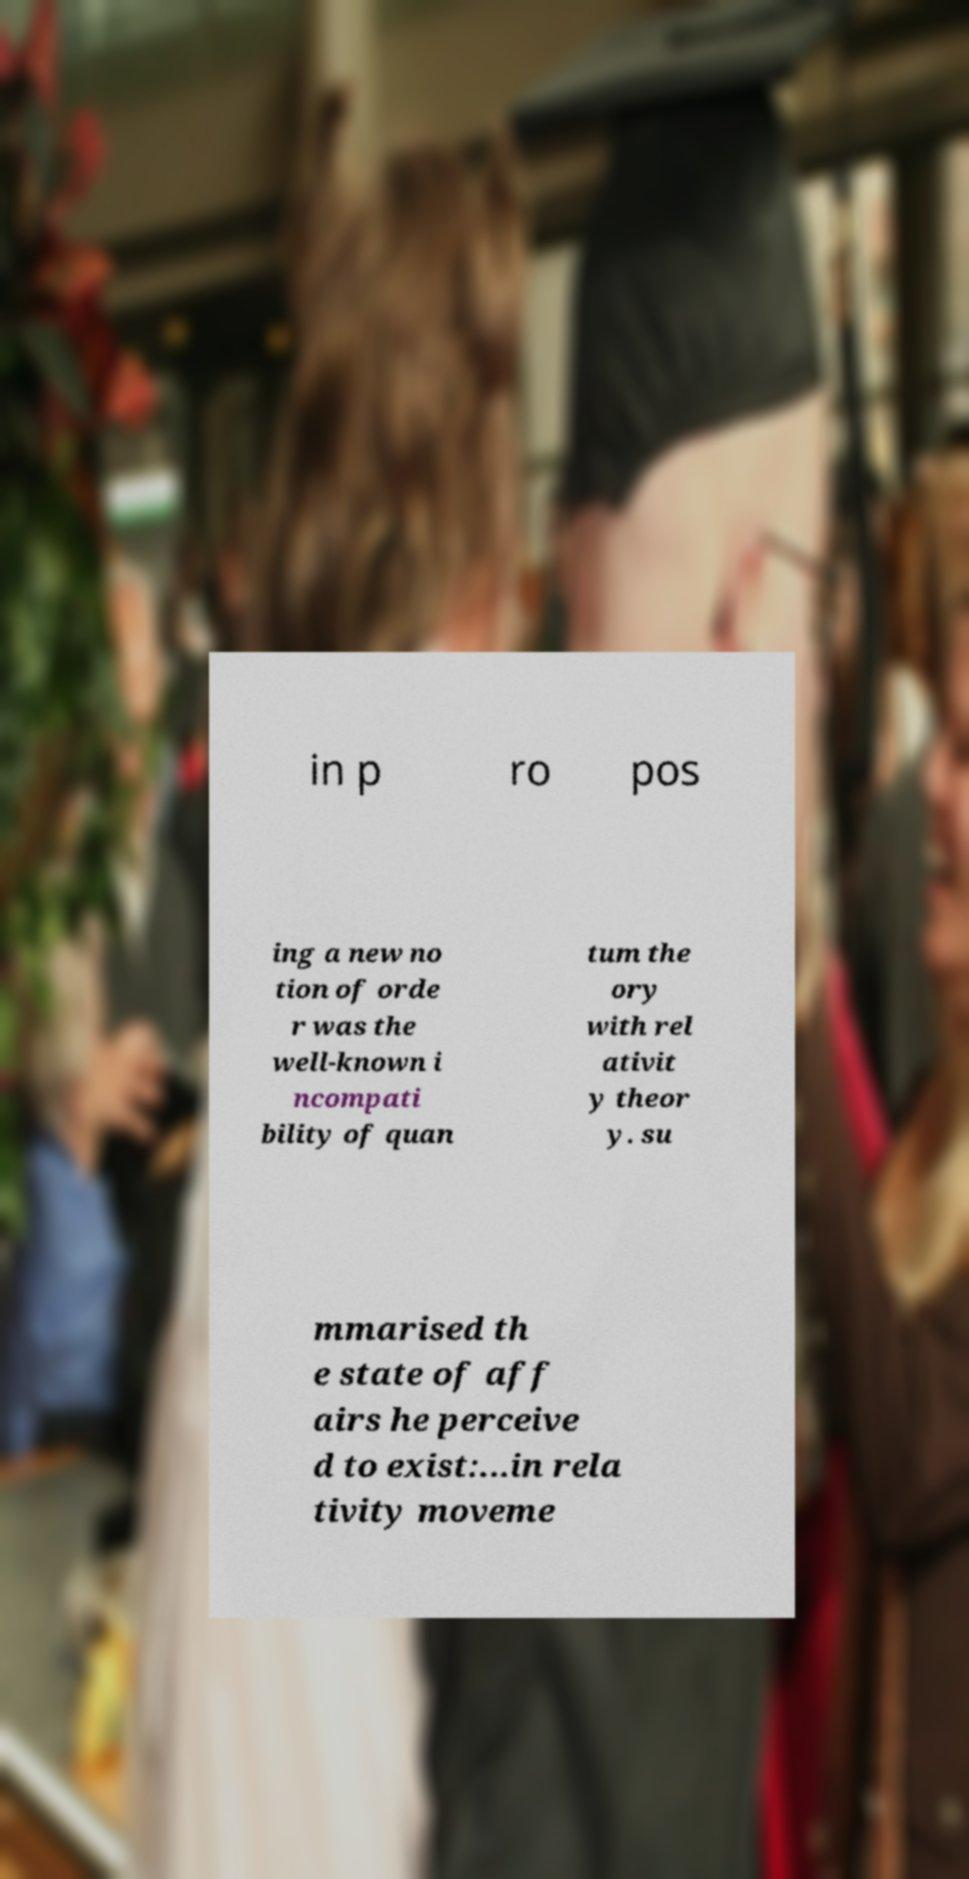There's text embedded in this image that I need extracted. Can you transcribe it verbatim? in p ro pos ing a new no tion of orde r was the well-known i ncompati bility of quan tum the ory with rel ativit y theor y. su mmarised th e state of aff airs he perceive d to exist:...in rela tivity moveme 